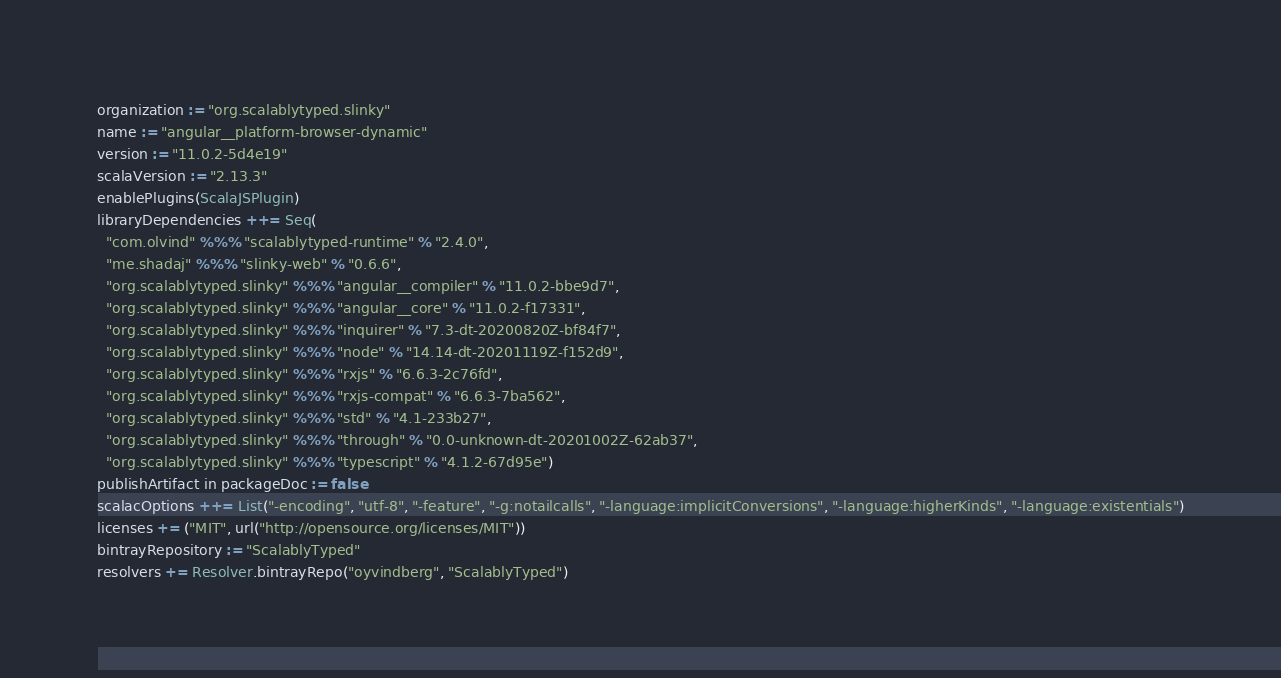<code> <loc_0><loc_0><loc_500><loc_500><_Scala_>organization := "org.scalablytyped.slinky"
name := "angular__platform-browser-dynamic"
version := "11.0.2-5d4e19"
scalaVersion := "2.13.3"
enablePlugins(ScalaJSPlugin)
libraryDependencies ++= Seq(
  "com.olvind" %%% "scalablytyped-runtime" % "2.4.0",
  "me.shadaj" %%% "slinky-web" % "0.6.6",
  "org.scalablytyped.slinky" %%% "angular__compiler" % "11.0.2-bbe9d7",
  "org.scalablytyped.slinky" %%% "angular__core" % "11.0.2-f17331",
  "org.scalablytyped.slinky" %%% "inquirer" % "7.3-dt-20200820Z-bf84f7",
  "org.scalablytyped.slinky" %%% "node" % "14.14-dt-20201119Z-f152d9",
  "org.scalablytyped.slinky" %%% "rxjs" % "6.6.3-2c76fd",
  "org.scalablytyped.slinky" %%% "rxjs-compat" % "6.6.3-7ba562",
  "org.scalablytyped.slinky" %%% "std" % "4.1-233b27",
  "org.scalablytyped.slinky" %%% "through" % "0.0-unknown-dt-20201002Z-62ab37",
  "org.scalablytyped.slinky" %%% "typescript" % "4.1.2-67d95e")
publishArtifact in packageDoc := false
scalacOptions ++= List("-encoding", "utf-8", "-feature", "-g:notailcalls", "-language:implicitConversions", "-language:higherKinds", "-language:existentials")
licenses += ("MIT", url("http://opensource.org/licenses/MIT"))
bintrayRepository := "ScalablyTyped"
resolvers += Resolver.bintrayRepo("oyvindberg", "ScalablyTyped")
</code> 